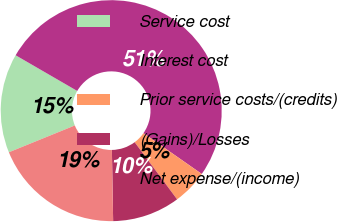Convert chart. <chart><loc_0><loc_0><loc_500><loc_500><pie_chart><fcel>Service cost<fcel>Interest cost<fcel>Prior service costs/(credits)<fcel>(Gains)/Losses<fcel>Net expense/(income)<nl><fcel>14.51%<fcel>51.36%<fcel>5.12%<fcel>9.89%<fcel>19.13%<nl></chart> 